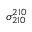<formula> <loc_0><loc_0><loc_500><loc_500>\sigma _ { 2 1 0 } ^ { 2 1 0 }</formula> 